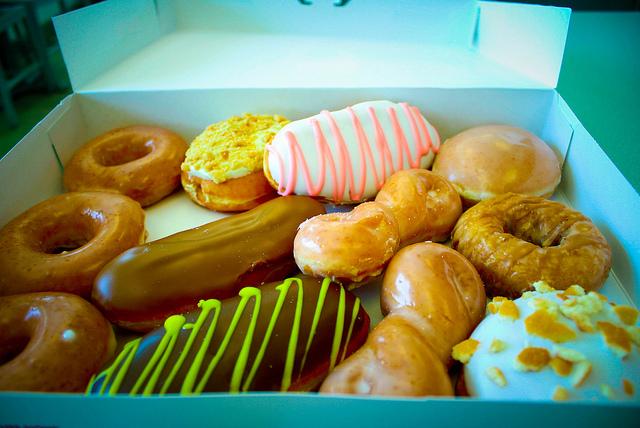Is this healthy?
Give a very brief answer. No. What is the desert in?
Answer briefly. Box. Are there any glazed doughnuts?
Concise answer only. Yes. 